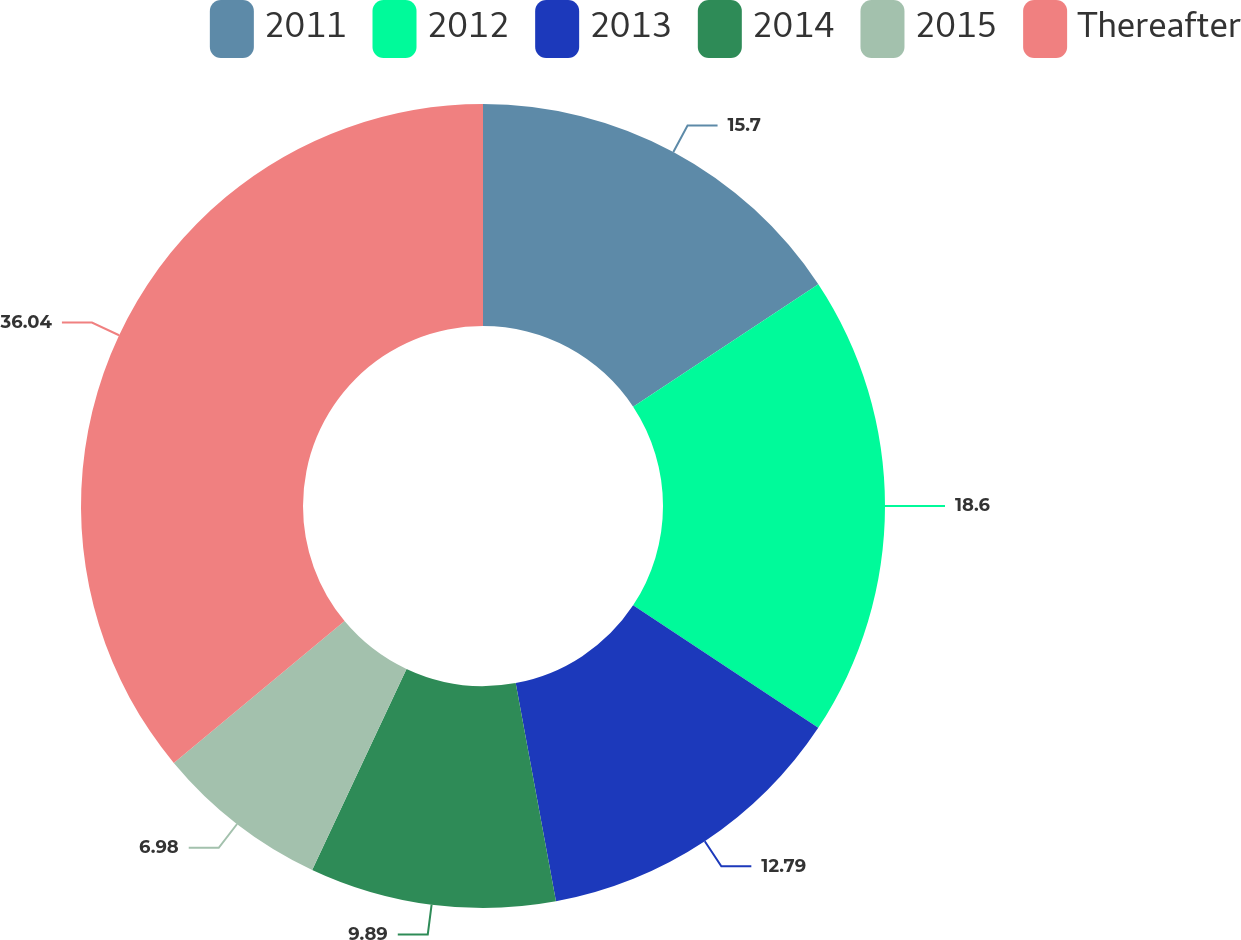Convert chart. <chart><loc_0><loc_0><loc_500><loc_500><pie_chart><fcel>2011<fcel>2012<fcel>2013<fcel>2014<fcel>2015<fcel>Thereafter<nl><fcel>15.7%<fcel>18.6%<fcel>12.79%<fcel>9.89%<fcel>6.98%<fcel>36.03%<nl></chart> 